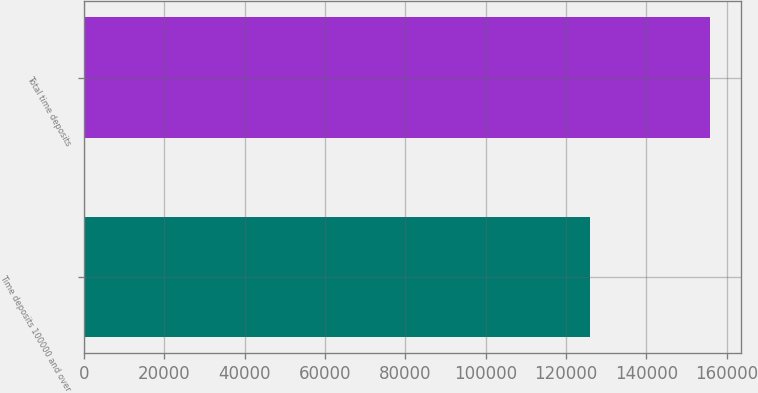Convert chart to OTSL. <chart><loc_0><loc_0><loc_500><loc_500><bar_chart><fcel>Time deposits 100000 and over<fcel>Total time deposits<nl><fcel>126002<fcel>155749<nl></chart> 